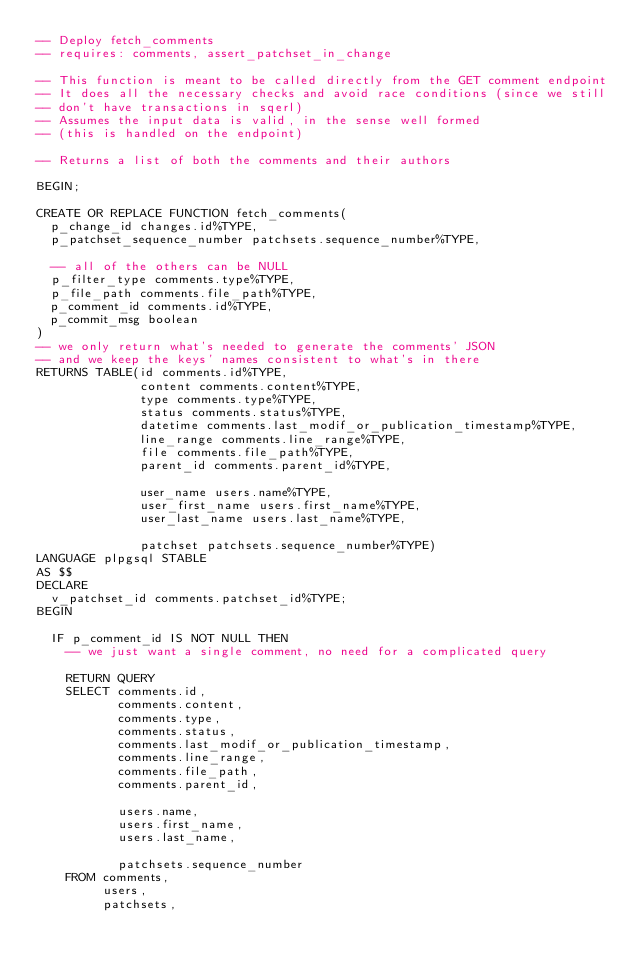<code> <loc_0><loc_0><loc_500><loc_500><_SQL_>-- Deploy fetch_comments
-- requires: comments, assert_patchset_in_change

-- This function is meant to be called directly from the GET comment endpoint
-- It does all the necessary checks and avoid race conditions (since we still
-- don't have transactions in sqerl)
-- Assumes the input data is valid, in the sense well formed
-- (this is handled on the endpoint)

-- Returns a list of both the comments and their authors

BEGIN;

CREATE OR REPLACE FUNCTION fetch_comments(
  p_change_id changes.id%TYPE,
  p_patchset_sequence_number patchsets.sequence_number%TYPE,

  -- all of the others can be NULL
  p_filter_type comments.type%TYPE,
  p_file_path comments.file_path%TYPE,
  p_comment_id comments.id%TYPE,
  p_commit_msg boolean
)
-- we only return what's needed to generate the comments' JSON
-- and we keep the keys' names consistent to what's in there
RETURNS TABLE(id comments.id%TYPE,
              content comments.content%TYPE,
              type comments.type%TYPE,
              status comments.status%TYPE,
              datetime comments.last_modif_or_publication_timestamp%TYPE,
              line_range comments.line_range%TYPE,
              file comments.file_path%TYPE,
              parent_id comments.parent_id%TYPE,

              user_name users.name%TYPE,
              user_first_name users.first_name%TYPE,
              user_last_name users.last_name%TYPE,

              patchset patchsets.sequence_number%TYPE)
LANGUAGE plpgsql STABLE
AS $$
DECLARE
  v_patchset_id comments.patchset_id%TYPE;
BEGIN

  IF p_comment_id IS NOT NULL THEN
    -- we just want a single comment, no need for a complicated query

    RETURN QUERY
    SELECT comments.id,
           comments.content,
           comments.type,
           comments.status,
           comments.last_modif_or_publication_timestamp,
           comments.line_range,
           comments.file_path,
           comments.parent_id,

           users.name,
           users.first_name,
           users.last_name,

           patchsets.sequence_number
    FROM comments,
         users,
         patchsets,</code> 